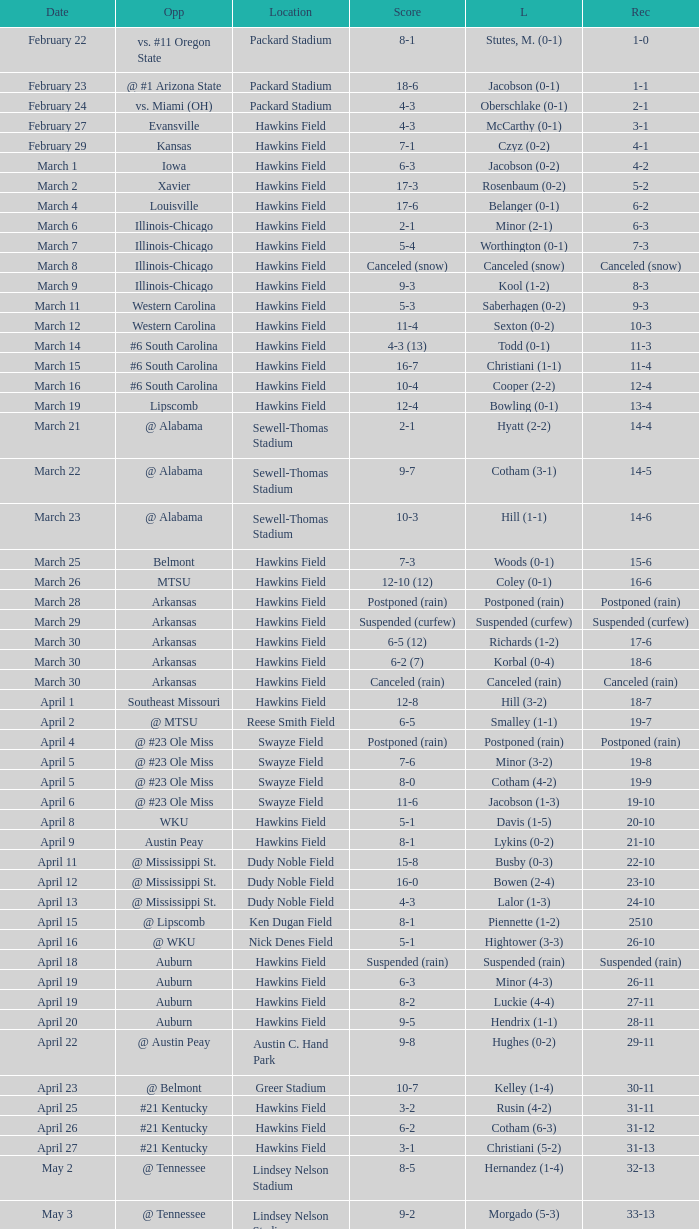What was the location of the game when the record was 2-1? Packard Stadium. 